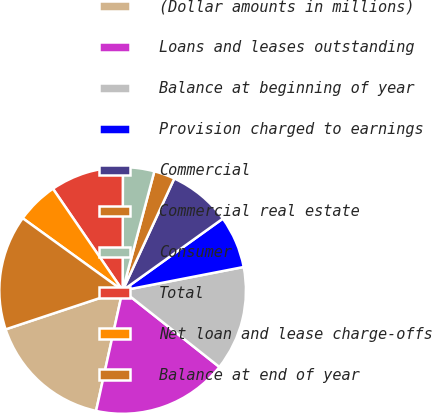Convert chart to OTSL. <chart><loc_0><loc_0><loc_500><loc_500><pie_chart><fcel>(Dollar amounts in millions)<fcel>Loans and leases outstanding<fcel>Balance at beginning of year<fcel>Provision charged to earnings<fcel>Commercial<fcel>Commercial real estate<fcel>Consumer<fcel>Total<fcel>Net loan and lease charge-offs<fcel>Balance at end of year<nl><fcel>16.44%<fcel>17.81%<fcel>13.7%<fcel>6.85%<fcel>8.22%<fcel>2.74%<fcel>4.11%<fcel>9.59%<fcel>5.48%<fcel>15.07%<nl></chart> 